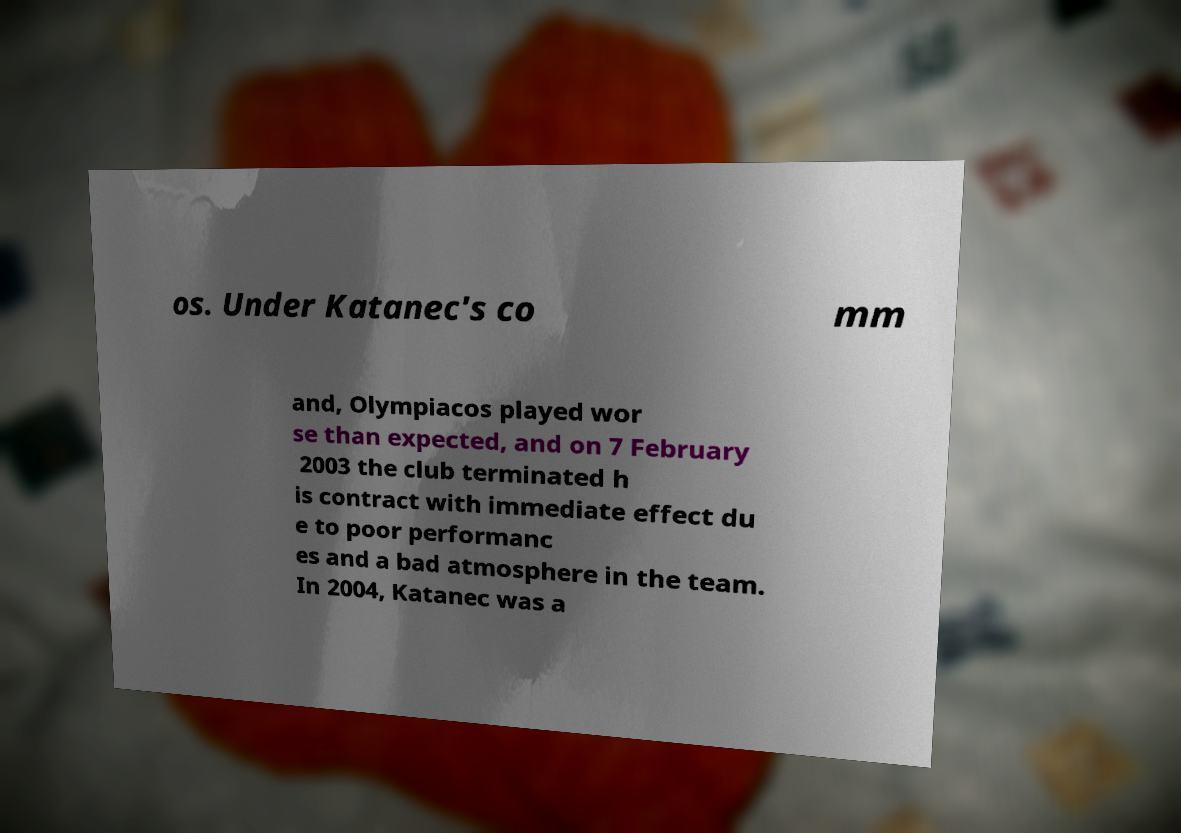For documentation purposes, I need the text within this image transcribed. Could you provide that? os. Under Katanec's co mm and, Olympiacos played wor se than expected, and on 7 February 2003 the club terminated h is contract with immediate effect du e to poor performanc es and a bad atmosphere in the team. In 2004, Katanec was a 